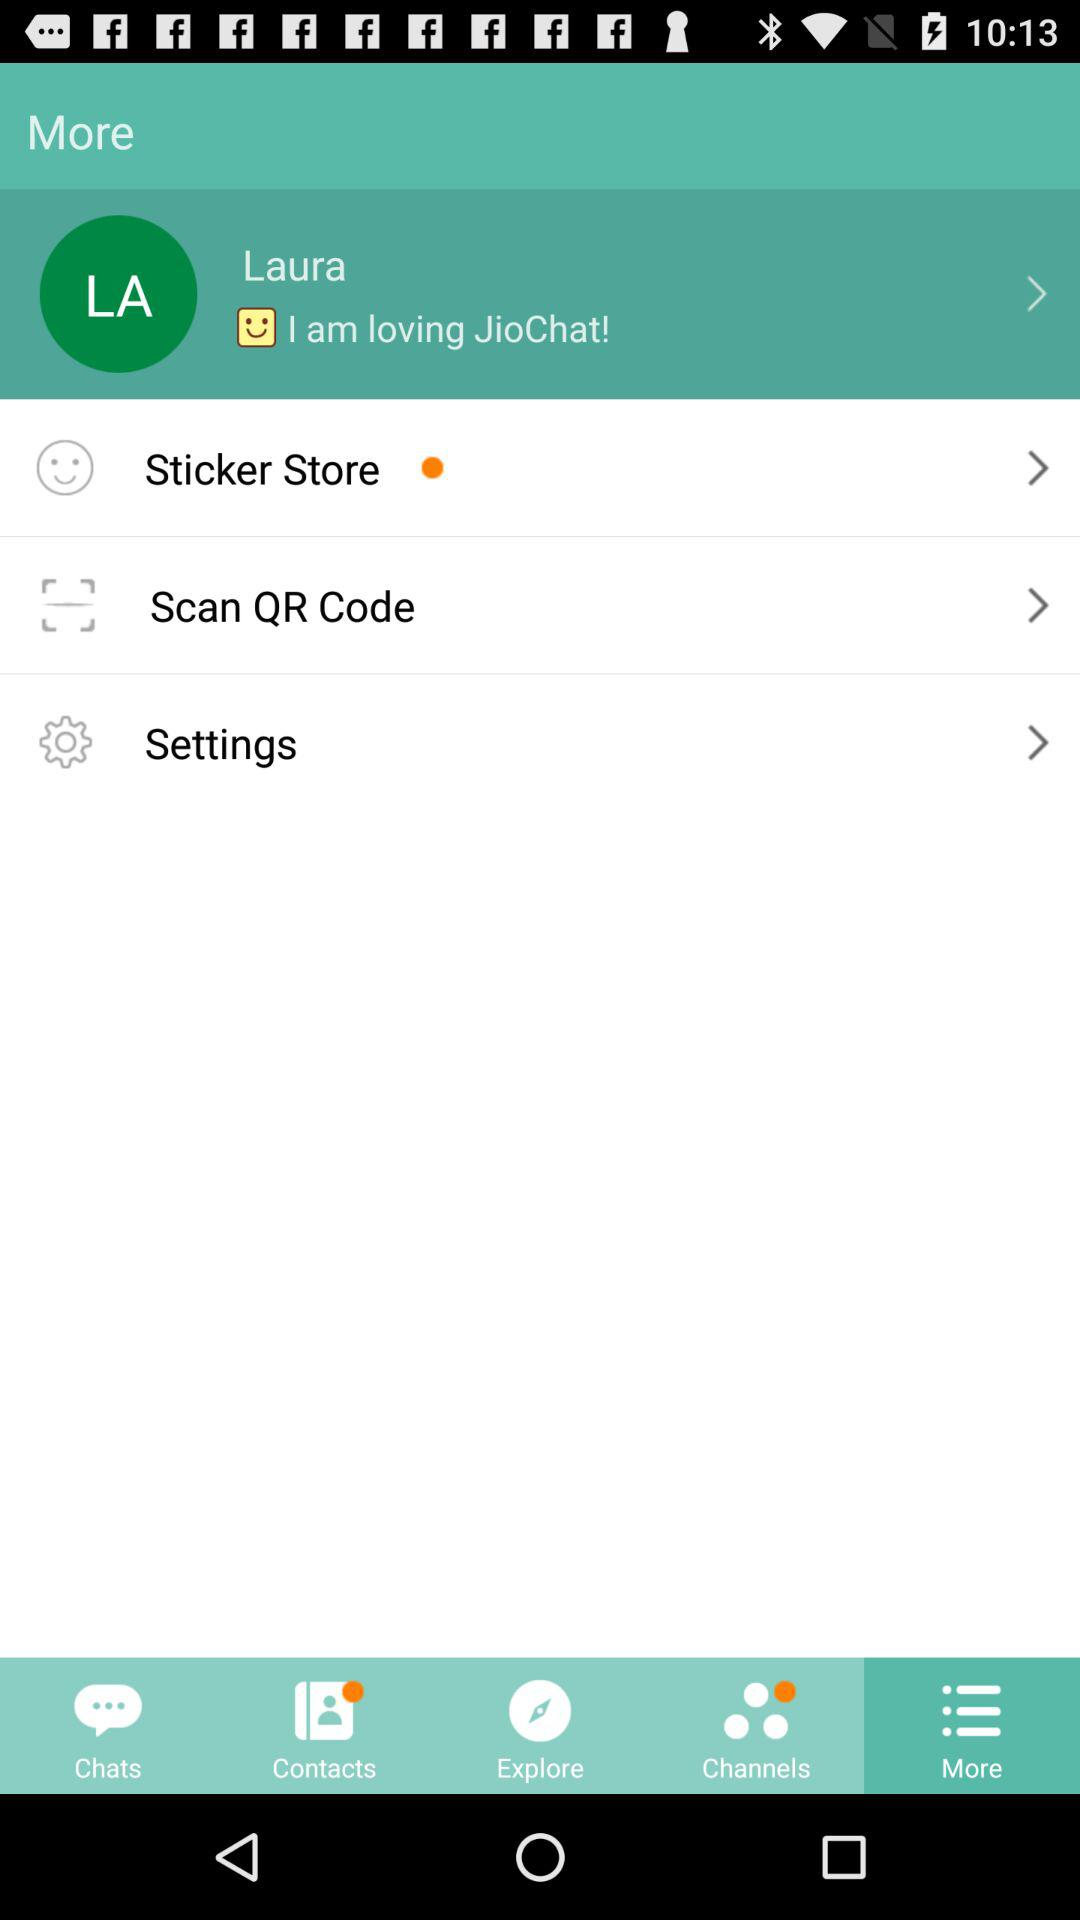Which tab am I using? You are using "More" tab. 